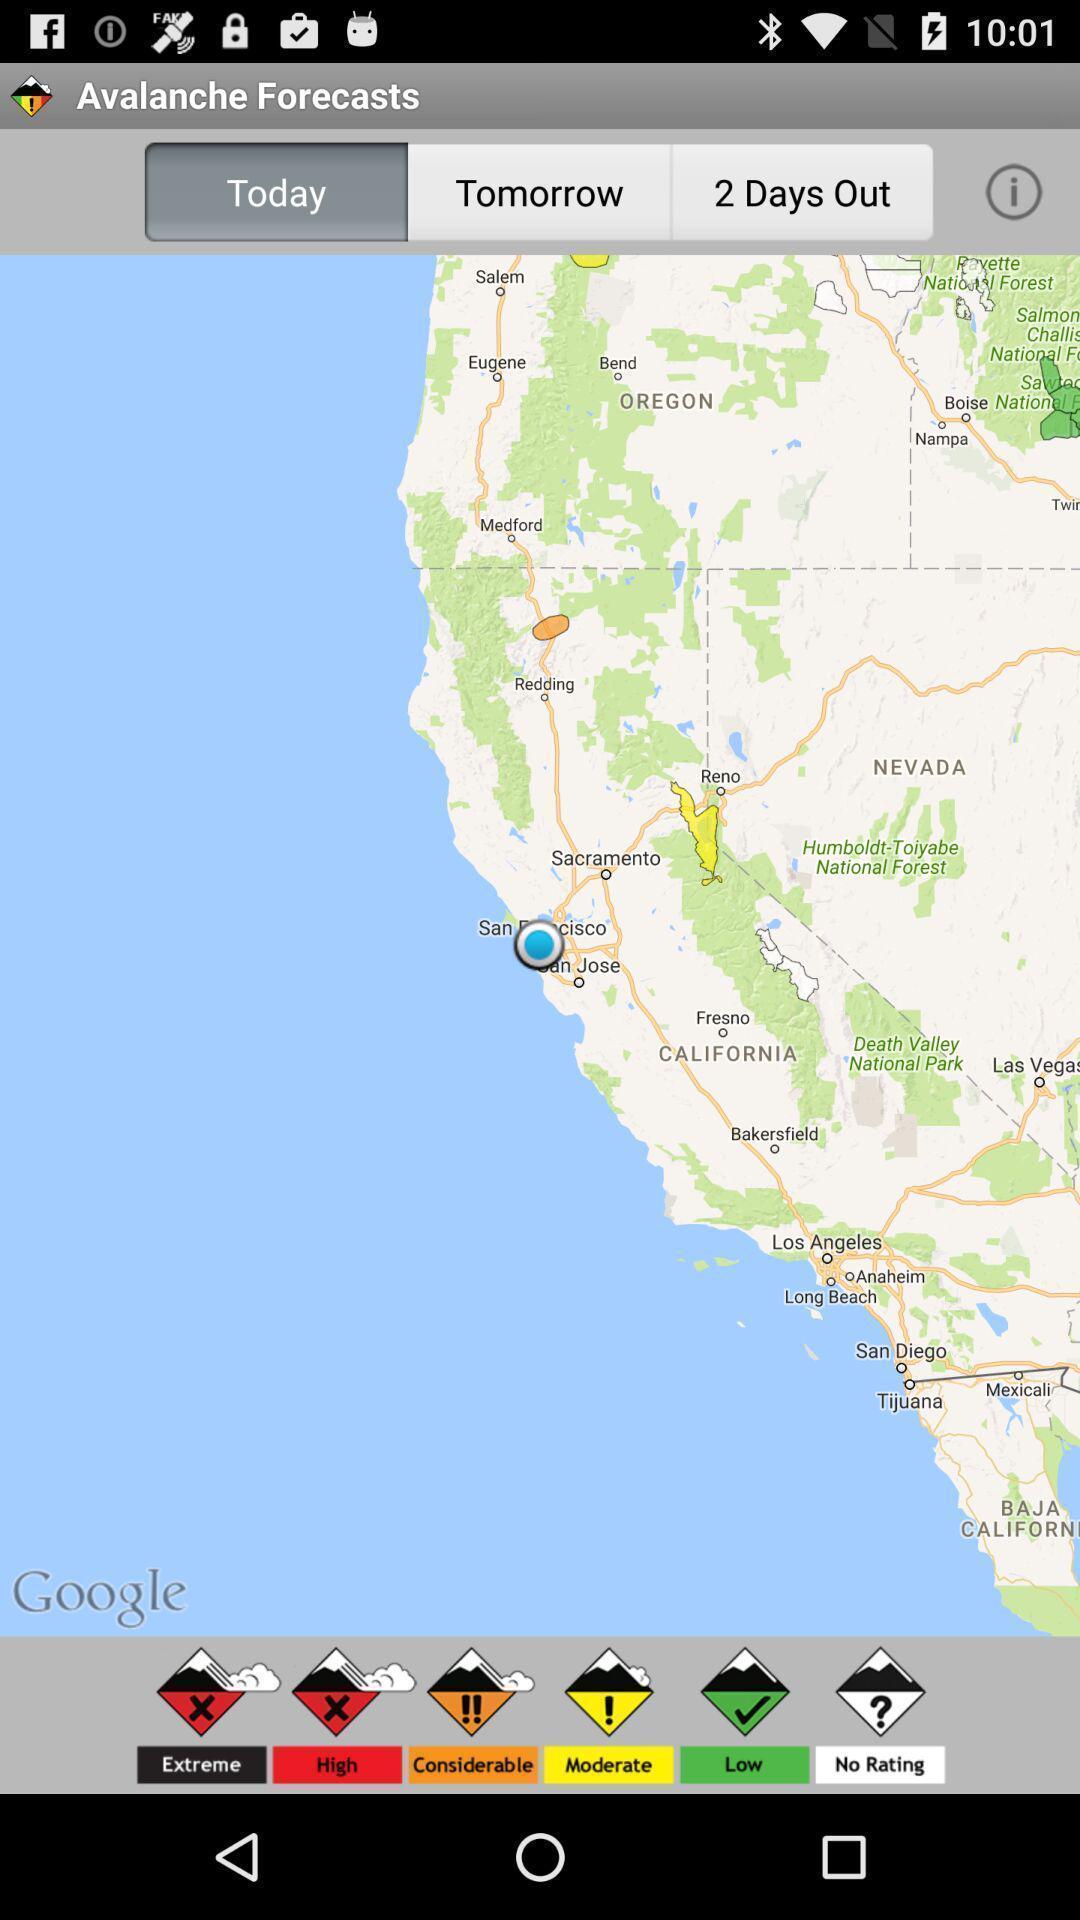Explain the elements present in this screenshot. Page displaying map. 